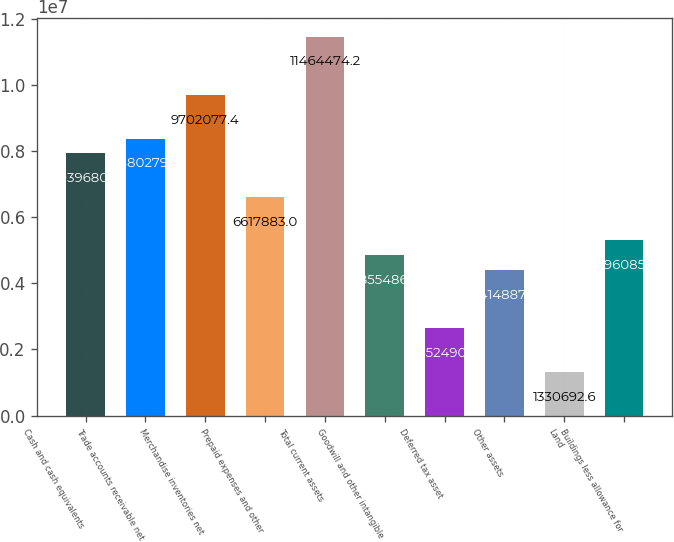Convert chart. <chart><loc_0><loc_0><loc_500><loc_500><bar_chart><fcel>Cash and cash equivalents<fcel>Trade accounts receivable net<fcel>Merchandise inventories net<fcel>Prepaid expenses and other<fcel>Total current assets<fcel>Goodwill and other intangible<fcel>Deferred tax asset<fcel>Other assets<fcel>Land<fcel>Buildings less allowance for<nl><fcel>7.93968e+06<fcel>8.38028e+06<fcel>9.70208e+06<fcel>6.61788e+06<fcel>1.14645e+07<fcel>4.85549e+06<fcel>2.65249e+06<fcel>4.41489e+06<fcel>1.33069e+06<fcel>5.29609e+06<nl></chart> 